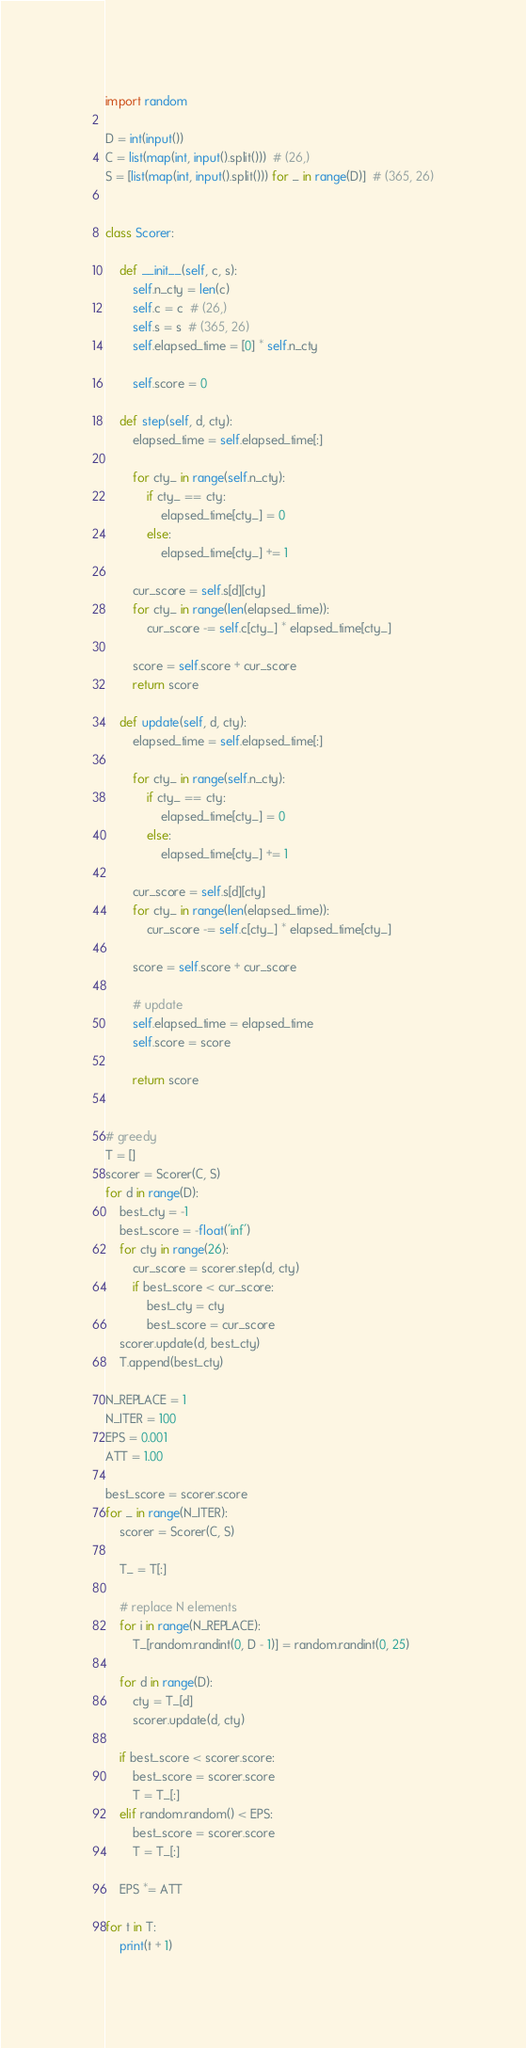<code> <loc_0><loc_0><loc_500><loc_500><_Python_>import random

D = int(input())
C = list(map(int, input().split()))  # (26,)
S = [list(map(int, input().split())) for _ in range(D)]  # (365, 26)


class Scorer:

    def __init__(self, c, s):
        self.n_cty = len(c)
        self.c = c  # (26,)
        self.s = s  # (365, 26)
        self.elapsed_time = [0] * self.n_cty

        self.score = 0

    def step(self, d, cty):
        elapsed_time = self.elapsed_time[:]

        for cty_ in range(self.n_cty):
            if cty_ == cty:
                elapsed_time[cty_] = 0
            else:
                elapsed_time[cty_] += 1

        cur_score = self.s[d][cty]
        for cty_ in range(len(elapsed_time)):
            cur_score -= self.c[cty_] * elapsed_time[cty_]

        score = self.score + cur_score
        return score

    def update(self, d, cty):
        elapsed_time = self.elapsed_time[:]

        for cty_ in range(self.n_cty):
            if cty_ == cty:
                elapsed_time[cty_] = 0
            else:
                elapsed_time[cty_] += 1

        cur_score = self.s[d][cty]
        for cty_ in range(len(elapsed_time)):
            cur_score -= self.c[cty_] * elapsed_time[cty_]

        score = self.score + cur_score

        # update
        self.elapsed_time = elapsed_time
        self.score = score

        return score


# greedy
T = []
scorer = Scorer(C, S)
for d in range(D):
    best_cty = -1
    best_score = -float('inf')
    for cty in range(26):
        cur_score = scorer.step(d, cty)
        if best_score < cur_score:
            best_cty = cty
            best_score = cur_score
    scorer.update(d, best_cty)
    T.append(best_cty)

N_REPLACE = 1
N_ITER = 100
EPS = 0.001
ATT = 1.00

best_score = scorer.score
for _ in range(N_ITER):
    scorer = Scorer(C, S)

    T_ = T[:]

    # replace N elements
    for i in range(N_REPLACE):
        T_[random.randint(0, D - 1)] = random.randint(0, 25)

    for d in range(D):
        cty = T_[d]
        scorer.update(d, cty)

    if best_score < scorer.score:
        best_score = scorer.score
        T = T_[:]
    elif random.random() < EPS:
        best_score = scorer.score
        T = T_[:]

    EPS *= ATT

for t in T:
    print(t + 1)

</code> 